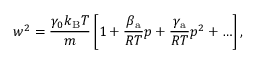<formula> <loc_0><loc_0><loc_500><loc_500>w ^ { 2 } = \frac { \gamma _ { 0 } k _ { B } T } { m } \left [ 1 + \frac { \beta _ { a } } { R T } p + \frac { \gamma _ { a } } { R T } p ^ { 2 } + \dots \right ] ,</formula> 